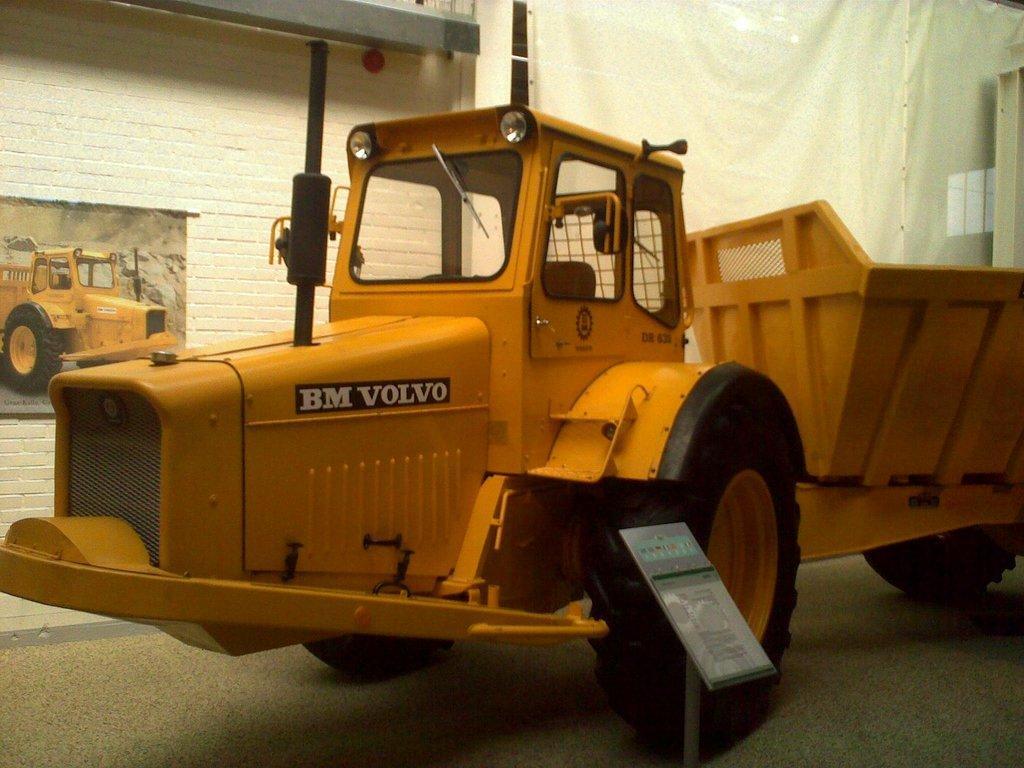Please provide a concise description of this image. In this image I can see a yellow colour vehicle and here I can see something is written. I can also see a stand over here and in the background I can see a photo of vehicle. 